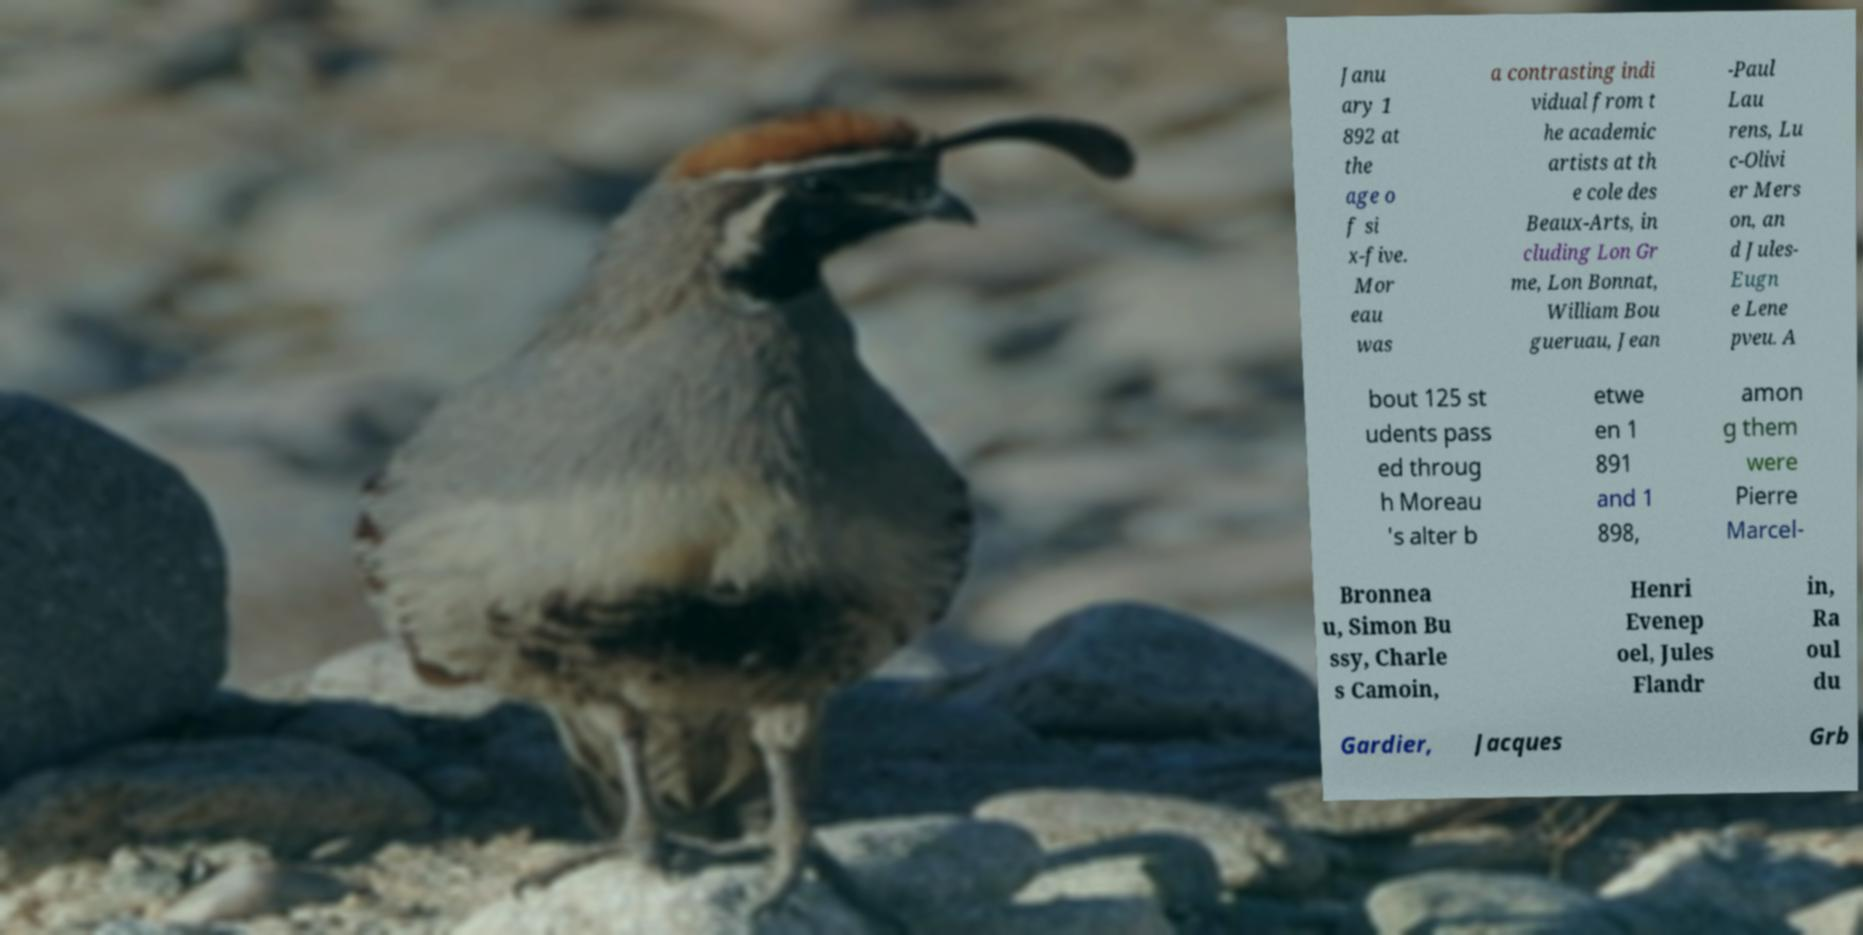I need the written content from this picture converted into text. Can you do that? Janu ary 1 892 at the age o f si x-five. Mor eau was a contrasting indi vidual from t he academic artists at th e cole des Beaux-Arts, in cluding Lon Gr me, Lon Bonnat, William Bou gueruau, Jean -Paul Lau rens, Lu c-Olivi er Mers on, an d Jules- Eugn e Lene pveu. A bout 125 st udents pass ed throug h Moreau 's alter b etwe en 1 891 and 1 898, amon g them were Pierre Marcel- Bronnea u, Simon Bu ssy, Charle s Camoin, Henri Evenep oel, Jules Flandr in, Ra oul du Gardier, Jacques Grb 